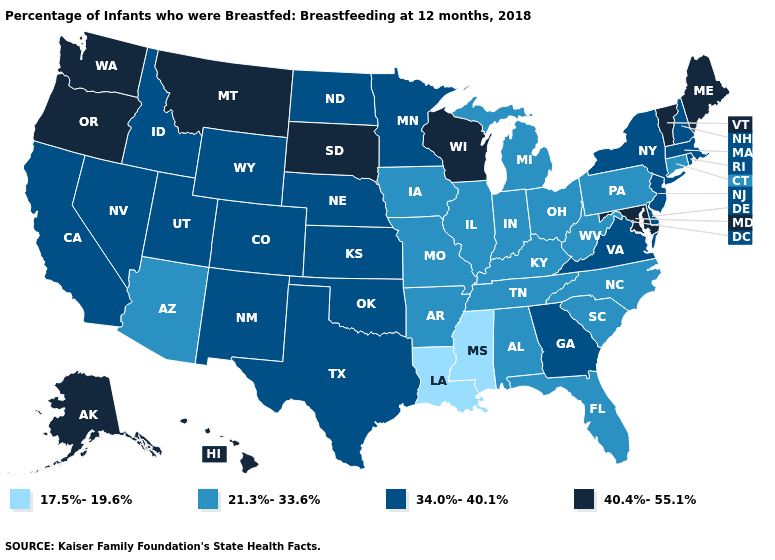What is the value of Michigan?
Answer briefly. 21.3%-33.6%. What is the highest value in states that border Nevada?
Concise answer only. 40.4%-55.1%. What is the value of Hawaii?
Keep it brief. 40.4%-55.1%. What is the value of Washington?
Give a very brief answer. 40.4%-55.1%. Name the states that have a value in the range 34.0%-40.1%?
Give a very brief answer. California, Colorado, Delaware, Georgia, Idaho, Kansas, Massachusetts, Minnesota, Nebraska, Nevada, New Hampshire, New Jersey, New Mexico, New York, North Dakota, Oklahoma, Rhode Island, Texas, Utah, Virginia, Wyoming. Does Wyoming have the highest value in the West?
Be succinct. No. What is the highest value in states that border North Dakota?
Give a very brief answer. 40.4%-55.1%. What is the value of Nebraska?
Answer briefly. 34.0%-40.1%. Is the legend a continuous bar?
Concise answer only. No. What is the value of Louisiana?
Give a very brief answer. 17.5%-19.6%. Among the states that border Louisiana , does Mississippi have the highest value?
Be succinct. No. Does Colorado have the lowest value in the USA?
Answer briefly. No. What is the value of Maryland?
Write a very short answer. 40.4%-55.1%. Among the states that border Colorado , does Arizona have the highest value?
Keep it brief. No. Does Louisiana have a higher value than California?
Give a very brief answer. No. 